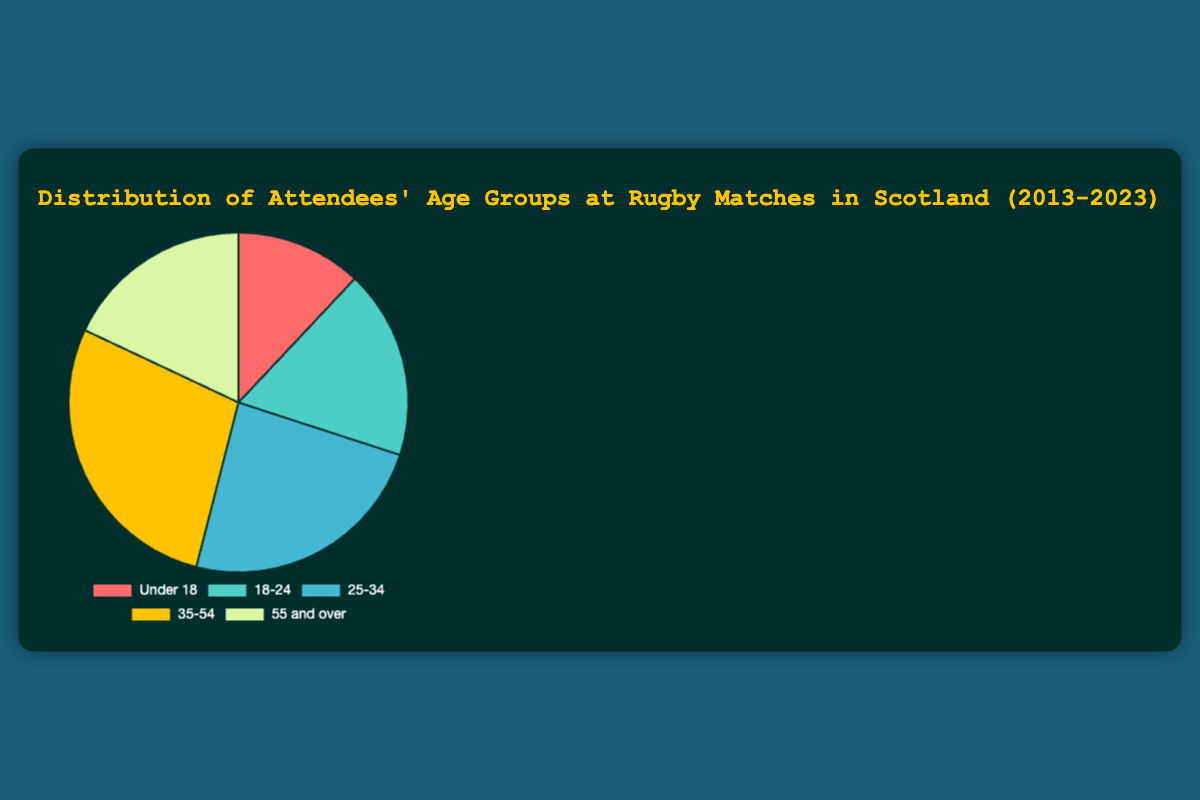What age group has the highest percentage of attendees? To determine the age group with the highest percentage, compare the percentages of all the age groups. The "35-54" group has the highest percentage at 28%.
Answer: 35-54 Which two age groups together make up 36% of attendees? To find two groups that together make up 36%, identify combinations of percentages that sum to 36%. The "Under 18" group (12%) and the "18-24" group (18%) together make up 30%, while pairing "18-24" (18%) and "55 and over" (18%) sums to 36%.
Answer: 18-24 and 55 and over What is the difference in percentage between the "25-34" and "35-54" age groups? Subtract the percentage of the "25-34" group (24%) from the "35-54" group (28%) to find the difference. 28% - 24% = 4%.
Answer: 4% Which age groups have an equal percentage of attendees? Compare the percentages of all the age groups. The "18-24" and "55 and over" age groups both have 18%.
Answer: 18-24 and 55 and over Which age group is represented by the green color in the pie chart? Identify the color associated with each age group in the chart. The "18-24" age group is represented by the green color.
Answer: 18-24 What is the combined percentage of attendees in the "Under 18" and "25-34" age groups? Add the percentages of the "Under 18" group (12%) and the "25-34" group (24%). 12% + 24% = 36%.
Answer: 36% How does the percentage of the "55 and over" age group compare to the "Under 18" age group? Compare the percentages of both groups. Both the "55 and over" and "Under 18" age groups have 18% and 12% respectively.
Answer: 55 and over has 6% more than Under 18 What is the percentage difference between the most and least represented age groups? Subtract the smallest percentage (12% for "Under 18") from the largest percentage (28% for "35-54"). 28% - 12% = 16%.
Answer: 16% Which age group has a larger percentage: "Under 18" or "18-24"? Compare the percentages of the "Under 18" group (12%) and the "18-24" group (18%). The "18-24" group has a larger percentage.
Answer: 18-24 What percentage of attendees are aged 35 and above? Add the percentages of the "35-54" (28%) and "55 and over" (18%) groups. 28% + 18% = 46%.
Answer: 46% 